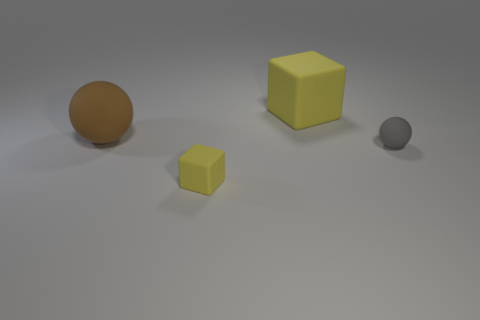Add 1 large gray balls. How many objects exist? 5 Subtract 0 blue cylinders. How many objects are left? 4 Subtract all big red balls. Subtract all gray matte balls. How many objects are left? 3 Add 4 yellow rubber things. How many yellow rubber things are left? 6 Add 4 small gray matte cubes. How many small gray matte cubes exist? 4 